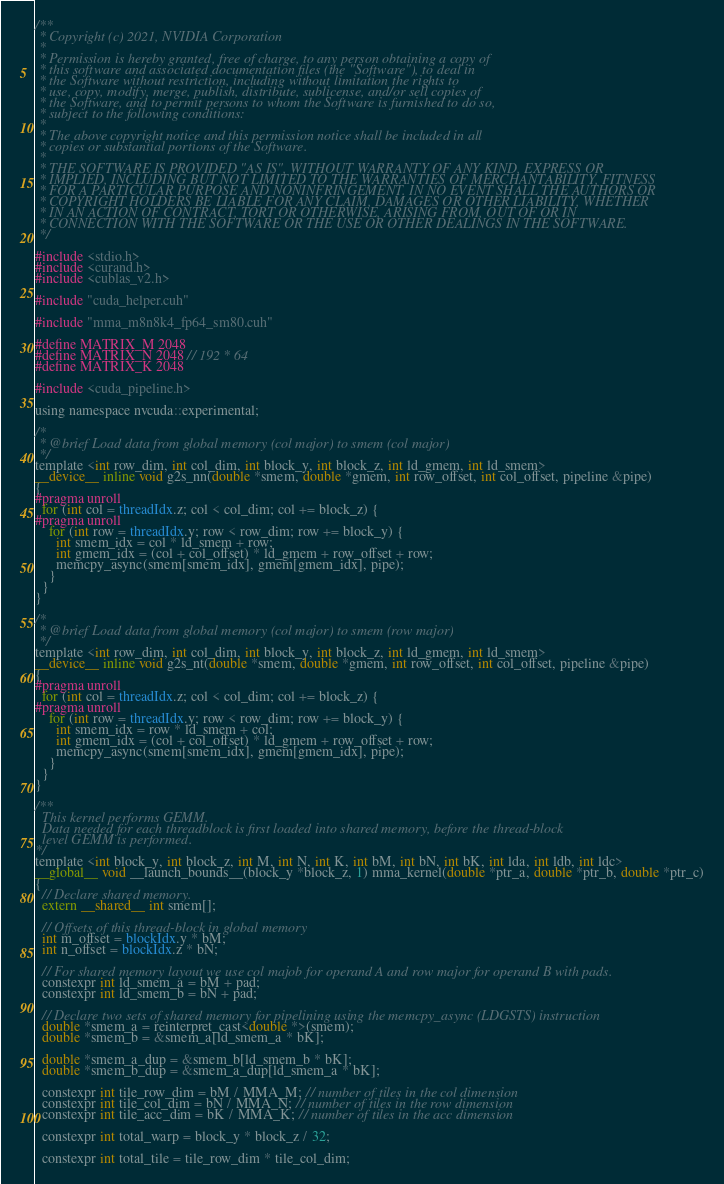Convert code to text. <code><loc_0><loc_0><loc_500><loc_500><_Cuda_>
/**
 * Copyright (c) 2021, NVIDIA Corporation
 *
 * Permission is hereby granted, free of charge, to any person obtaining a copy of
 * this software and associated documentation files (the "Software"), to deal in
 * the Software without restriction, including without limitation the rights to
 * use, copy, modify, merge, publish, distribute, sublicense, and/or sell copies of
 * the Software, and to permit persons to whom the Software is furnished to do so,
 * subject to the following conditions:
 *
 * The above copyright notice and this permission notice shall be included in all
 * copies or substantial portions of the Software.
 *
 * THE SOFTWARE IS PROVIDED "AS IS", WITHOUT WARRANTY OF ANY KIND, EXPRESS OR
 * IMPLIED, INCLUDING BUT NOT LIMITED TO THE WARRANTIES OF MERCHANTABILITY, FITNESS
 * FOR A PARTICULAR PURPOSE AND NONINFRINGEMENT. IN NO EVENT SHALL THE AUTHORS OR
 * COPYRIGHT HOLDERS BE LIABLE FOR ANY CLAIM, DAMAGES OR OTHER LIABILITY, WHETHER
 * IN AN ACTION OF CONTRACT, TORT OR OTHERWISE, ARISING FROM, OUT OF OR IN
 * CONNECTION WITH THE SOFTWARE OR THE USE OR OTHER DEALINGS IN THE SOFTWARE.
 */

#include <stdio.h>
#include <curand.h>
#include <cublas_v2.h>

#include "cuda_helper.cuh"

#include "mma_m8n8k4_fp64_sm80.cuh"

#define MATRIX_M 2048
#define MATRIX_N 2048 // 192 * 64
#define MATRIX_K 2048

#include <cuda_pipeline.h>

using namespace nvcuda::experimental;

/*
 * @brief Load data from global memory (col major) to smem (col major)
 */
template <int row_dim, int col_dim, int block_y, int block_z, int ld_gmem, int ld_smem>
__device__ inline void g2s_nn(double *smem, double *gmem, int row_offset, int col_offset, pipeline &pipe)
{
#pragma unroll
  for (int col = threadIdx.z; col < col_dim; col += block_z) {
#pragma unroll
    for (int row = threadIdx.y; row < row_dim; row += block_y) {
      int smem_idx = col * ld_smem + row;
      int gmem_idx = (col + col_offset) * ld_gmem + row_offset + row;
      memcpy_async(smem[smem_idx], gmem[gmem_idx], pipe);
    }
  }
}

/*
 * @brief Load data from global memory (col major) to smem (row major)
 */
template <int row_dim, int col_dim, int block_y, int block_z, int ld_gmem, int ld_smem>
__device__ inline void g2s_nt(double *smem, double *gmem, int row_offset, int col_offset, pipeline &pipe)
{
#pragma unroll
  for (int col = threadIdx.z; col < col_dim; col += block_z) {
#pragma unroll
    for (int row = threadIdx.y; row < row_dim; row += block_y) {
      int smem_idx = row * ld_smem + col;
      int gmem_idx = (col + col_offset) * ld_gmem + row_offset + row;
      memcpy_async(smem[smem_idx], gmem[gmem_idx], pipe);
    }
  }
}

/**
  This kernel performs GEMM.
  Data needed for each threadblock is first loaded into shared memory, before the thread-block
  level GEMM is performed.
*/
template <int block_y, int block_z, int M, int N, int K, int bM, int bN, int bK, int lda, int ldb, int ldc>
__global__ void __launch_bounds__(block_y *block_z, 1) mma_kernel(double *ptr_a, double *ptr_b, double *ptr_c)
{
  // Declare shared memory.
  extern __shared__ int smem[];

  // Offsets of this thread-block in global memory
  int m_offset = blockIdx.y * bM;
  int n_offset = blockIdx.z * bN;

  // For shared memory layout we use col majob for operand A and row major for operand B with pads.
  constexpr int ld_smem_a = bM + pad;
  constexpr int ld_smem_b = bN + pad;

  // Declare two sets of shared memory for pipelining using the memcpy_async (LDGSTS) instruction
  double *smem_a = reinterpret_cast<double *>(smem);
  double *smem_b = &smem_a[ld_smem_a * bK];

  double *smem_a_dup = &smem_b[ld_smem_b * bK];
  double *smem_b_dup = &smem_a_dup[ld_smem_a * bK];

  constexpr int tile_row_dim = bM / MMA_M; // number of tiles in the col dimension
  constexpr int tile_col_dim = bN / MMA_N; // number of tiles in the row dimension
  constexpr int tile_acc_dim = bK / MMA_K; // number of tiles in the acc dimension

  constexpr int total_warp = block_y * block_z / 32;

  constexpr int total_tile = tile_row_dim * tile_col_dim;</code> 